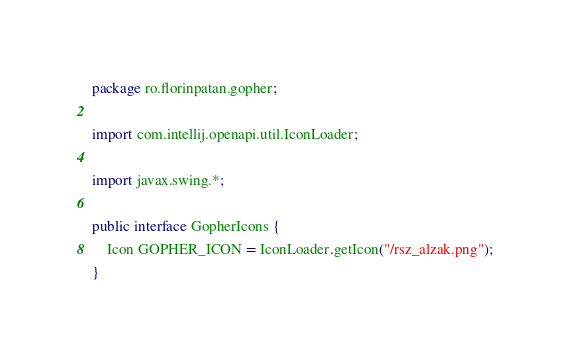<code> <loc_0><loc_0><loc_500><loc_500><_Java_>package ro.florinpatan.gopher;

import com.intellij.openapi.util.IconLoader;

import javax.swing.*;

public interface GopherIcons {
    Icon GOPHER_ICON = IconLoader.getIcon("/rsz_alzak.png");
}
</code> 